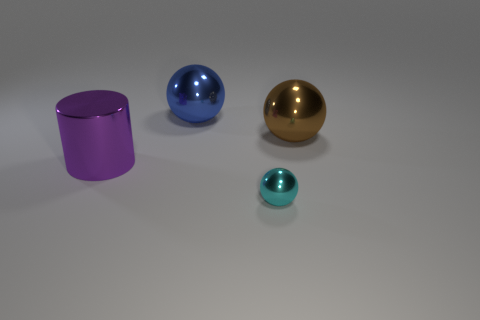Add 1 shiny cylinders. How many objects exist? 5 Subtract all large brown metal spheres. How many spheres are left? 2 Subtract all spheres. How many objects are left? 1 Subtract all green cubes. How many brown balls are left? 1 Subtract all gray spheres. Subtract all small cyan metal balls. How many objects are left? 3 Add 4 shiny spheres. How many shiny spheres are left? 7 Add 1 big blue metallic objects. How many big blue metallic objects exist? 2 Subtract 0 blue cubes. How many objects are left? 4 Subtract 1 cylinders. How many cylinders are left? 0 Subtract all blue cylinders. Subtract all blue blocks. How many cylinders are left? 1 